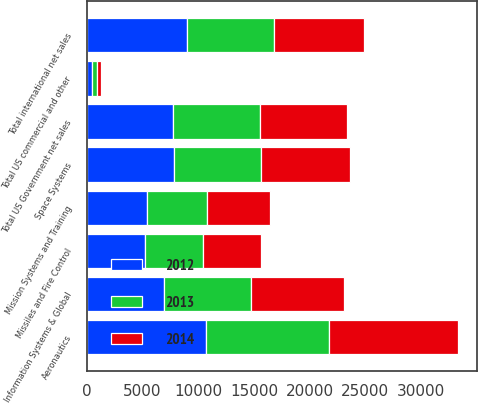<chart> <loc_0><loc_0><loc_500><loc_500><stacked_bar_chart><ecel><fcel>Aeronautics<fcel>Information Systems & Global<fcel>Missiles and Fire Control<fcel>Mission Systems and Training<fcel>Space Systems<fcel>Total US Government net sales<fcel>Total international net sales<fcel>Total US commercial and other<nl><fcel>2012<fcel>10704<fcel>6951<fcel>5223<fcel>5395<fcel>7817<fcel>7768<fcel>9015<fcel>495<nl><fcel>2013<fcel>11025<fcel>7768<fcel>5177<fcel>5370<fcel>7833<fcel>7768<fcel>7768<fcel>417<nl><fcel>2014<fcel>11587<fcel>8340<fcel>5224<fcel>5685<fcel>7952<fcel>7768<fcel>8056<fcel>338<nl></chart> 